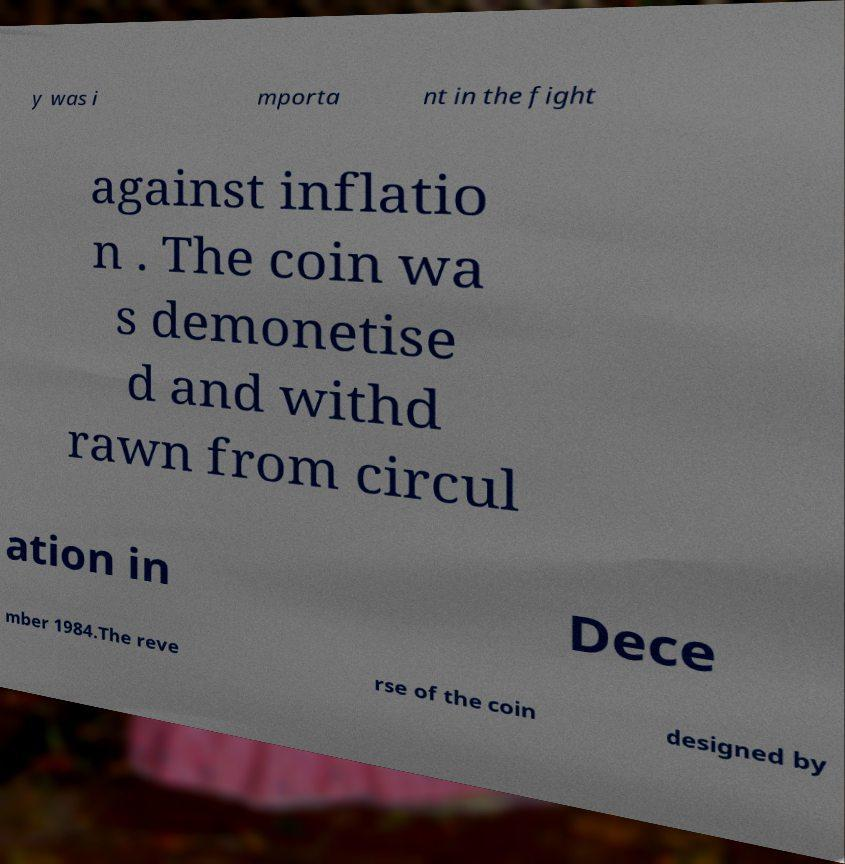Could you assist in decoding the text presented in this image and type it out clearly? y was i mporta nt in the fight against inflatio n . The coin wa s demonetise d and withd rawn from circul ation in Dece mber 1984.The reve rse of the coin designed by 